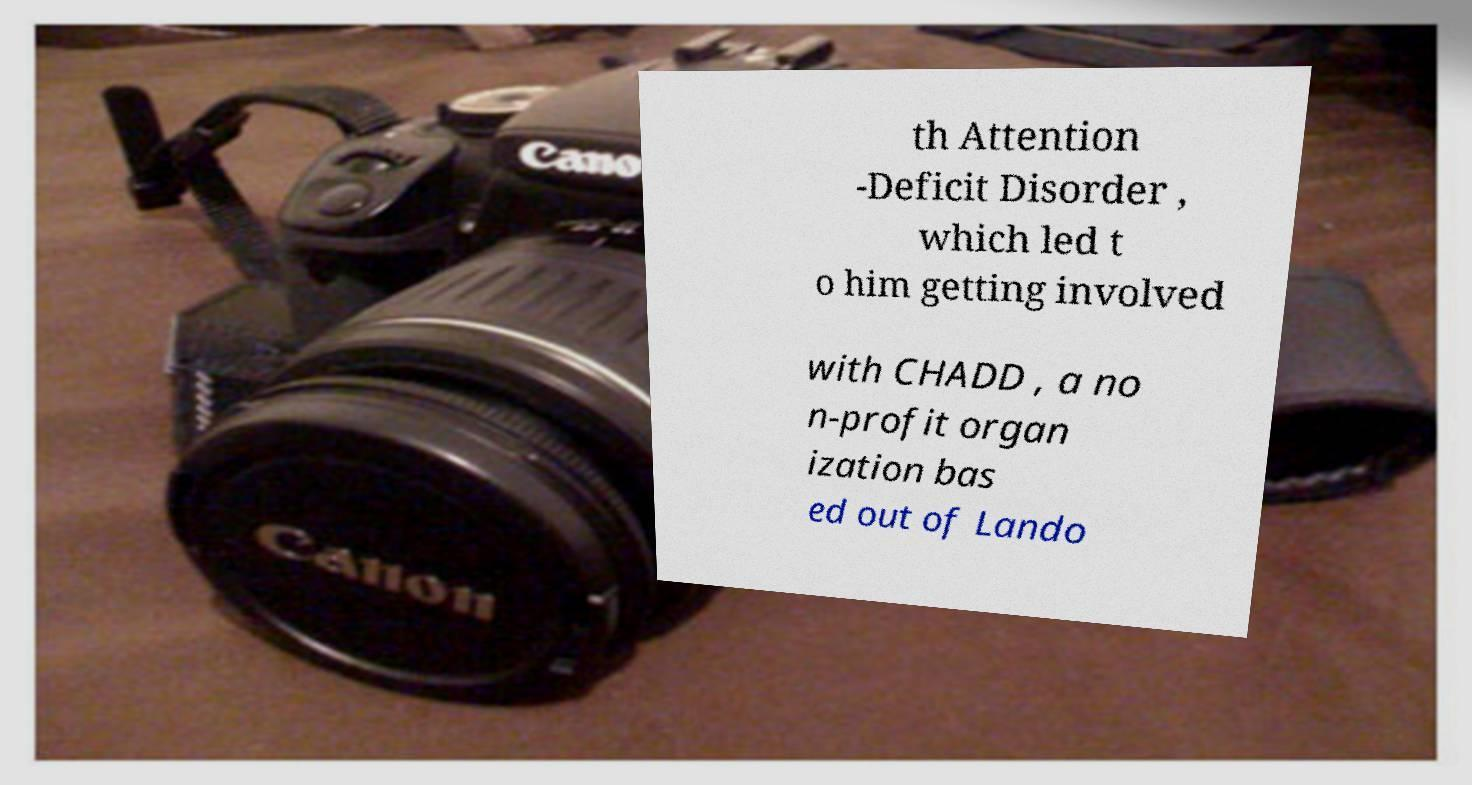Can you read and provide the text displayed in the image?This photo seems to have some interesting text. Can you extract and type it out for me? th Attention -Deficit Disorder , which led t o him getting involved with CHADD , a no n-profit organ ization bas ed out of Lando 